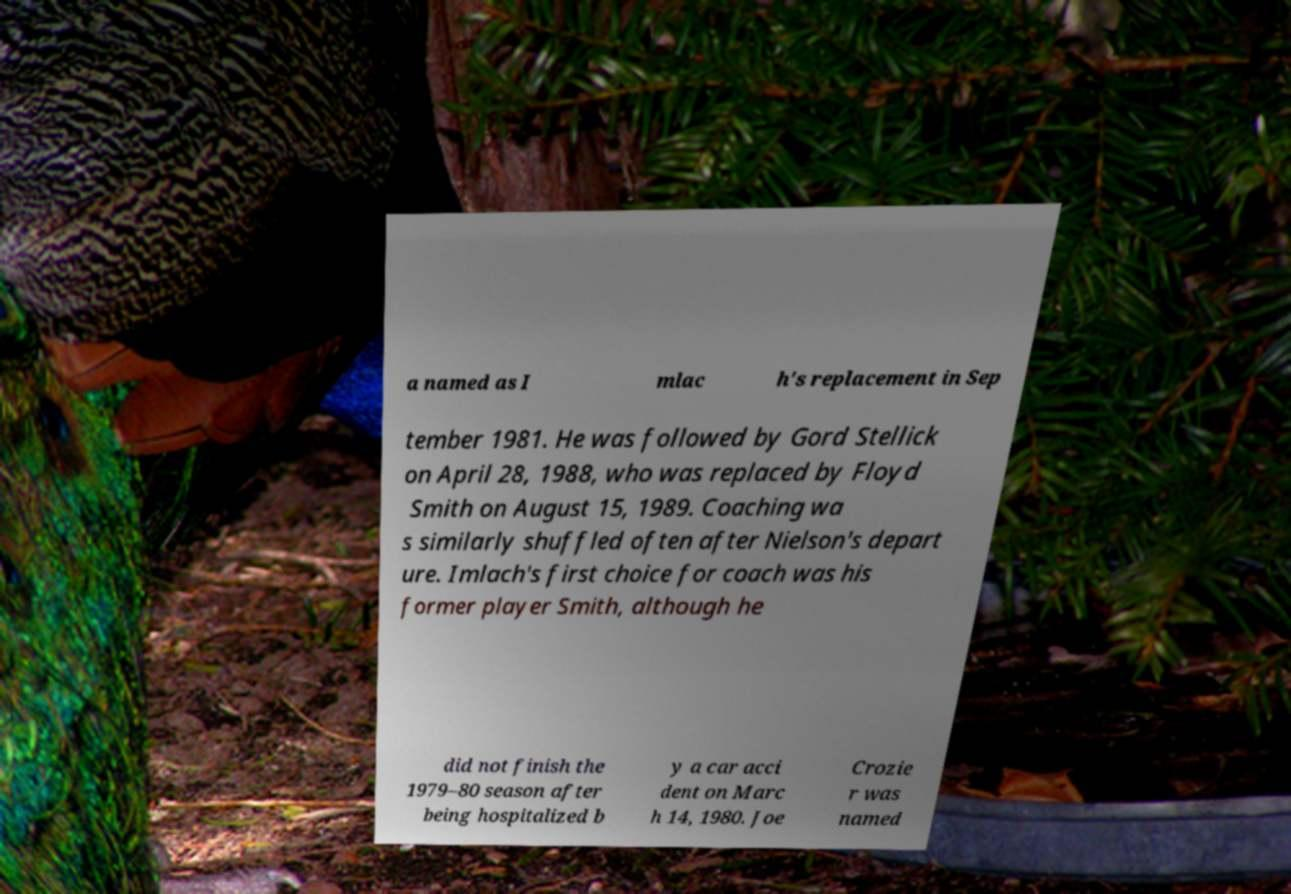For documentation purposes, I need the text within this image transcribed. Could you provide that? a named as I mlac h's replacement in Sep tember 1981. He was followed by Gord Stellick on April 28, 1988, who was replaced by Floyd Smith on August 15, 1989. Coaching wa s similarly shuffled often after Nielson's depart ure. Imlach's first choice for coach was his former player Smith, although he did not finish the 1979–80 season after being hospitalized b y a car acci dent on Marc h 14, 1980. Joe Crozie r was named 